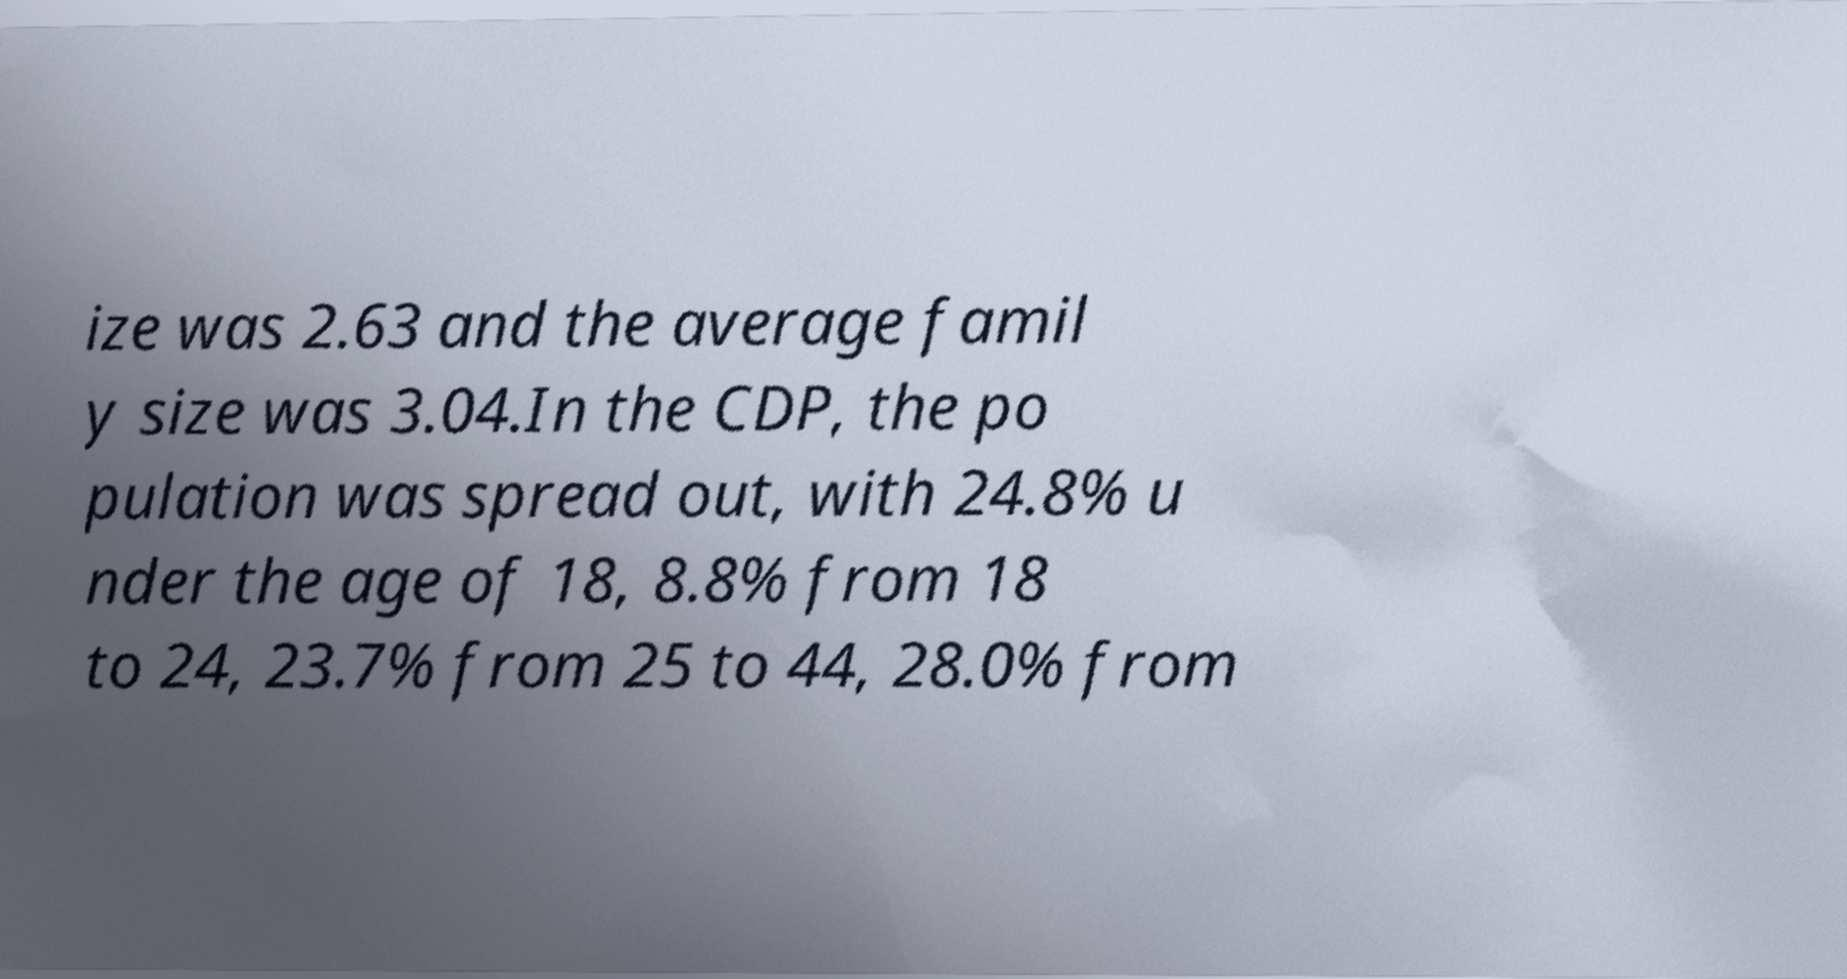For documentation purposes, I need the text within this image transcribed. Could you provide that? ize was 2.63 and the average famil y size was 3.04.In the CDP, the po pulation was spread out, with 24.8% u nder the age of 18, 8.8% from 18 to 24, 23.7% from 25 to 44, 28.0% from 